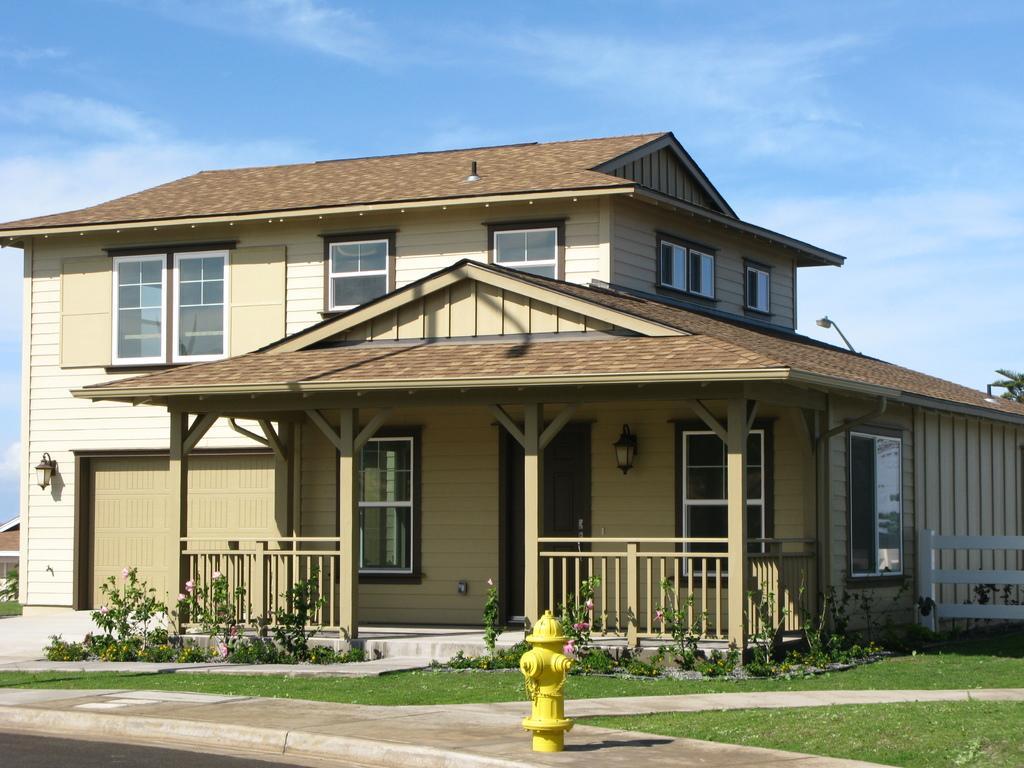Describe this image in one or two sentences. In the center of the image there is a building. At the bottom there is a hydrant and we can see shrubs. In the background there is sky. 